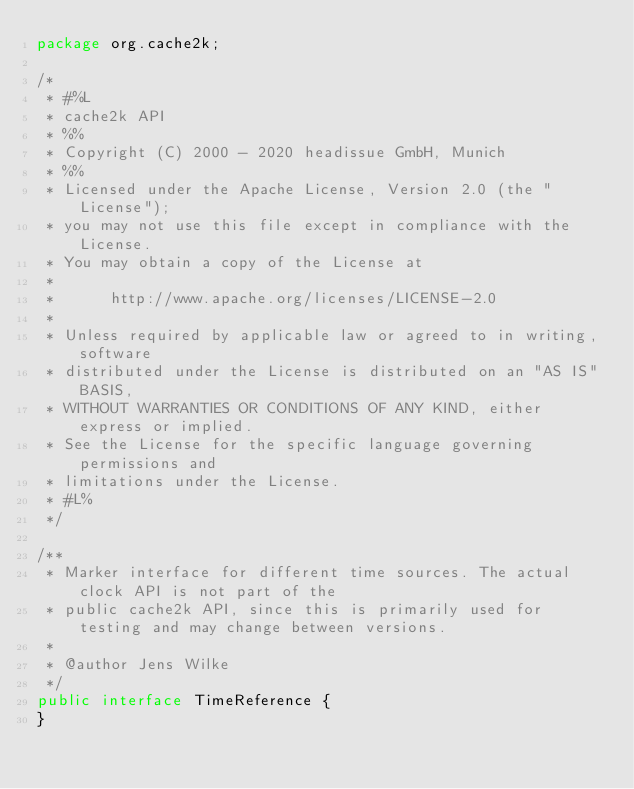Convert code to text. <code><loc_0><loc_0><loc_500><loc_500><_Java_>package org.cache2k;

/*
 * #%L
 * cache2k API
 * %%
 * Copyright (C) 2000 - 2020 headissue GmbH, Munich
 * %%
 * Licensed under the Apache License, Version 2.0 (the "License");
 * you may not use this file except in compliance with the License.
 * You may obtain a copy of the License at
 * 
 *      http://www.apache.org/licenses/LICENSE-2.0
 * 
 * Unless required by applicable law or agreed to in writing, software
 * distributed under the License is distributed on an "AS IS" BASIS,
 * WITHOUT WARRANTIES OR CONDITIONS OF ANY KIND, either express or implied.
 * See the License for the specific language governing permissions and
 * limitations under the License.
 * #L%
 */

/**
 * Marker interface for different time sources. The actual clock API is not part of the
 * public cache2k API, since this is primarily used for testing and may change between versions.
 *
 * @author Jens Wilke
 */
public interface TimeReference {
}
</code> 